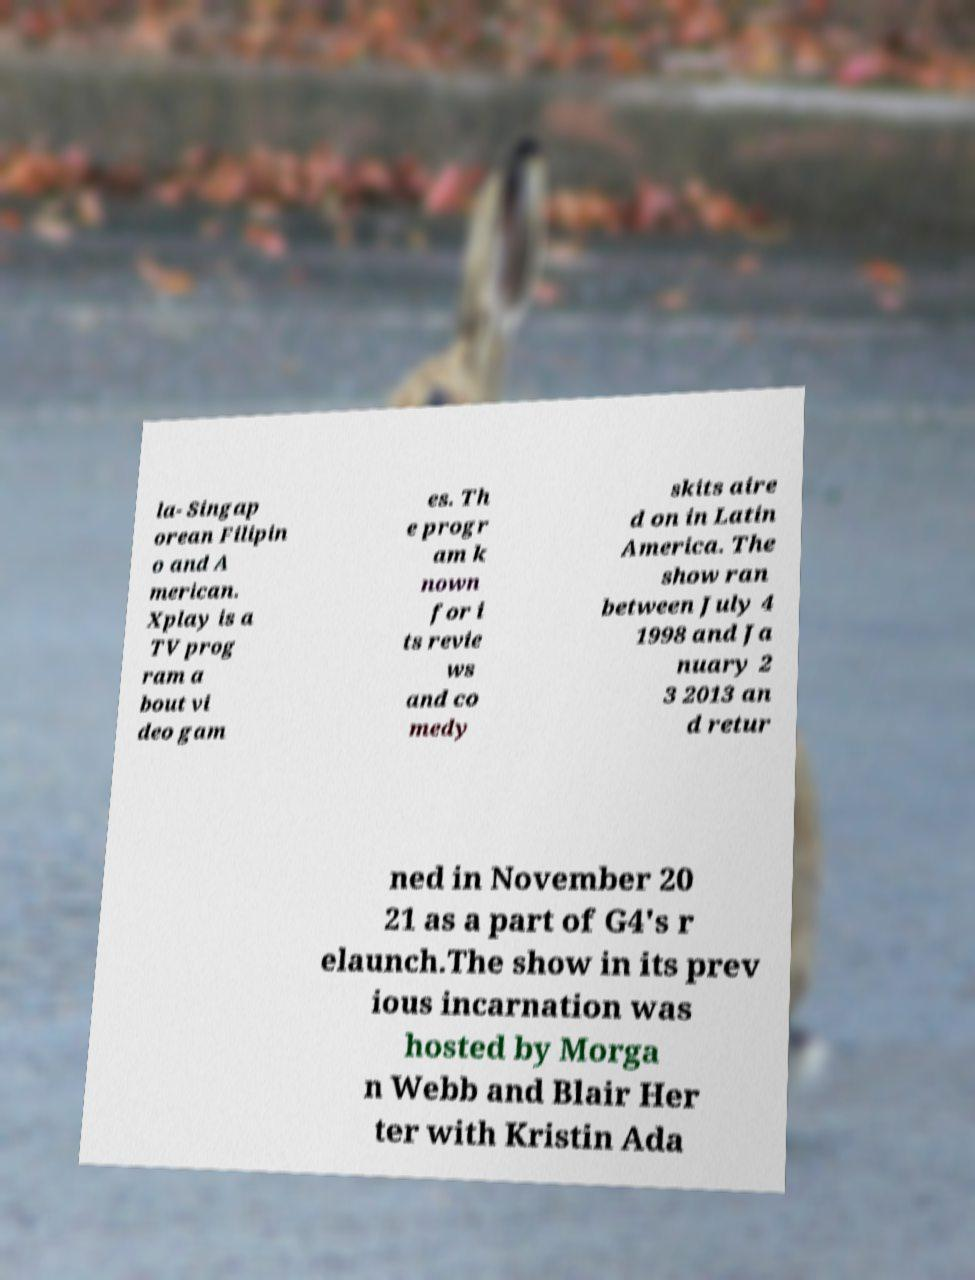What messages or text are displayed in this image? I need them in a readable, typed format. la- Singap orean Filipin o and A merican. Xplay is a TV prog ram a bout vi deo gam es. Th e progr am k nown for i ts revie ws and co medy skits aire d on in Latin America. The show ran between July 4 1998 and Ja nuary 2 3 2013 an d retur ned in November 20 21 as a part of G4's r elaunch.The show in its prev ious incarnation was hosted by Morga n Webb and Blair Her ter with Kristin Ada 